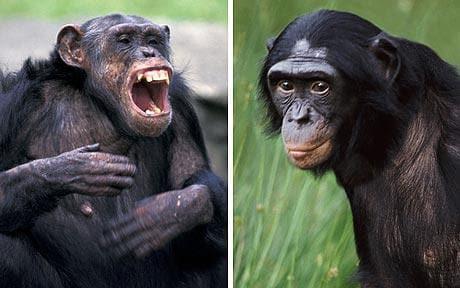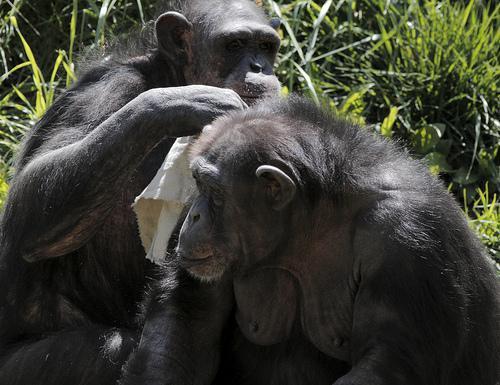The first image is the image on the left, the second image is the image on the right. Considering the images on both sides, is "One chimp has a wide open mouth showing its front row of teeth." valid? Answer yes or no. Yes. The first image is the image on the left, the second image is the image on the right. Analyze the images presented: Is the assertion "One of the animals in the image on the left has its teeth exposed." valid? Answer yes or no. Yes. 